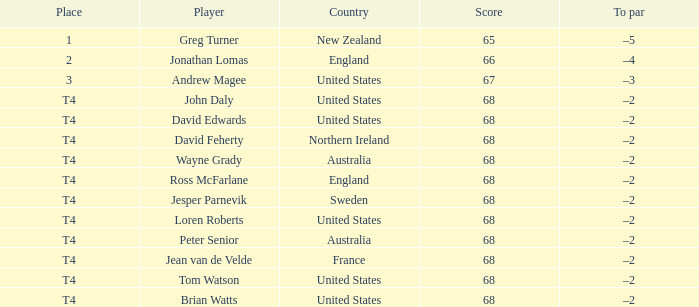Who has a to par of -2 and belongs to the united states? John Daly, David Edwards, Loren Roberts, Tom Watson, Brian Watts. 